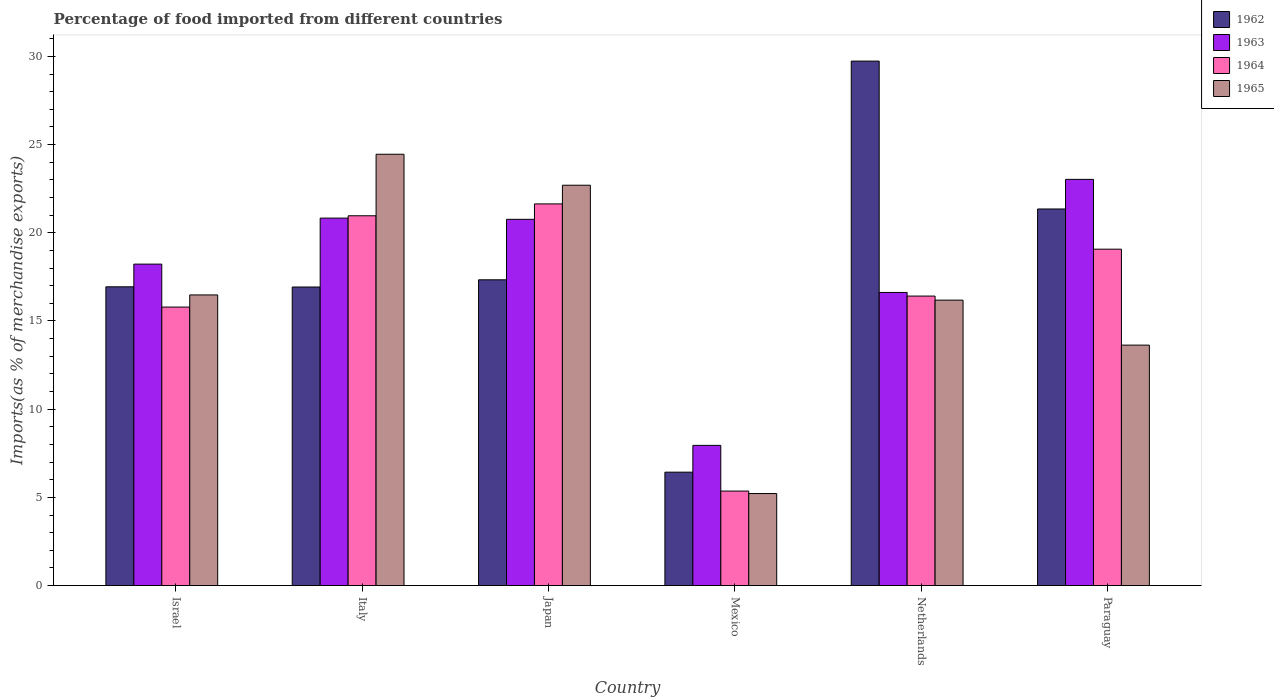How many different coloured bars are there?
Keep it short and to the point. 4. How many bars are there on the 6th tick from the right?
Your response must be concise. 4. What is the label of the 6th group of bars from the left?
Offer a terse response. Paraguay. In how many cases, is the number of bars for a given country not equal to the number of legend labels?
Your answer should be compact. 0. What is the percentage of imports to different countries in 1965 in Paraguay?
Provide a succinct answer. 13.63. Across all countries, what is the maximum percentage of imports to different countries in 1963?
Offer a very short reply. 23.03. Across all countries, what is the minimum percentage of imports to different countries in 1964?
Your answer should be very brief. 5.36. In which country was the percentage of imports to different countries in 1963 minimum?
Offer a very short reply. Mexico. What is the total percentage of imports to different countries in 1963 in the graph?
Ensure brevity in your answer.  107.42. What is the difference between the percentage of imports to different countries in 1964 in Italy and that in Mexico?
Offer a terse response. 15.61. What is the difference between the percentage of imports to different countries in 1964 in Paraguay and the percentage of imports to different countries in 1963 in Israel?
Offer a very short reply. 0.85. What is the average percentage of imports to different countries in 1963 per country?
Ensure brevity in your answer.  17.9. What is the difference between the percentage of imports to different countries of/in 1963 and percentage of imports to different countries of/in 1962 in Mexico?
Provide a short and direct response. 1.52. What is the ratio of the percentage of imports to different countries in 1965 in Japan to that in Netherlands?
Provide a succinct answer. 1.4. Is the percentage of imports to different countries in 1964 in Israel less than that in Mexico?
Give a very brief answer. No. Is the difference between the percentage of imports to different countries in 1963 in Italy and Paraguay greater than the difference between the percentage of imports to different countries in 1962 in Italy and Paraguay?
Ensure brevity in your answer.  Yes. What is the difference between the highest and the second highest percentage of imports to different countries in 1962?
Offer a very short reply. -4.02. What is the difference between the highest and the lowest percentage of imports to different countries in 1964?
Offer a very short reply. 16.28. Is the sum of the percentage of imports to different countries in 1965 in Italy and Mexico greater than the maximum percentage of imports to different countries in 1964 across all countries?
Provide a short and direct response. Yes. Is it the case that in every country, the sum of the percentage of imports to different countries in 1964 and percentage of imports to different countries in 1965 is greater than the sum of percentage of imports to different countries in 1962 and percentage of imports to different countries in 1963?
Give a very brief answer. No. What does the 1st bar from the right in Mexico represents?
Your answer should be very brief. 1965. Is it the case that in every country, the sum of the percentage of imports to different countries in 1964 and percentage of imports to different countries in 1963 is greater than the percentage of imports to different countries in 1965?
Ensure brevity in your answer.  Yes. How many bars are there?
Provide a succinct answer. 24. How many countries are there in the graph?
Provide a succinct answer. 6. Are the values on the major ticks of Y-axis written in scientific E-notation?
Ensure brevity in your answer.  No. Does the graph contain grids?
Provide a short and direct response. No. How many legend labels are there?
Offer a terse response. 4. What is the title of the graph?
Your answer should be very brief. Percentage of food imported from different countries. Does "1993" appear as one of the legend labels in the graph?
Make the answer very short. No. What is the label or title of the Y-axis?
Give a very brief answer. Imports(as % of merchandise exports). What is the Imports(as % of merchandise exports) in 1962 in Israel?
Ensure brevity in your answer.  16.94. What is the Imports(as % of merchandise exports) of 1963 in Israel?
Make the answer very short. 18.22. What is the Imports(as % of merchandise exports) of 1964 in Israel?
Make the answer very short. 15.79. What is the Imports(as % of merchandise exports) in 1965 in Israel?
Your answer should be compact. 16.48. What is the Imports(as % of merchandise exports) in 1962 in Italy?
Provide a short and direct response. 16.93. What is the Imports(as % of merchandise exports) in 1963 in Italy?
Offer a terse response. 20.83. What is the Imports(as % of merchandise exports) in 1964 in Italy?
Give a very brief answer. 20.97. What is the Imports(as % of merchandise exports) in 1965 in Italy?
Offer a terse response. 24.45. What is the Imports(as % of merchandise exports) of 1962 in Japan?
Ensure brevity in your answer.  17.34. What is the Imports(as % of merchandise exports) of 1963 in Japan?
Your answer should be compact. 20.76. What is the Imports(as % of merchandise exports) in 1964 in Japan?
Provide a short and direct response. 21.64. What is the Imports(as % of merchandise exports) of 1965 in Japan?
Keep it short and to the point. 22.7. What is the Imports(as % of merchandise exports) of 1962 in Mexico?
Make the answer very short. 6.43. What is the Imports(as % of merchandise exports) of 1963 in Mexico?
Provide a short and direct response. 7.95. What is the Imports(as % of merchandise exports) of 1964 in Mexico?
Offer a very short reply. 5.36. What is the Imports(as % of merchandise exports) in 1965 in Mexico?
Give a very brief answer. 5.22. What is the Imports(as % of merchandise exports) of 1962 in Netherlands?
Give a very brief answer. 29.73. What is the Imports(as % of merchandise exports) of 1963 in Netherlands?
Provide a short and direct response. 16.62. What is the Imports(as % of merchandise exports) in 1964 in Netherlands?
Make the answer very short. 16.41. What is the Imports(as % of merchandise exports) of 1965 in Netherlands?
Offer a very short reply. 16.18. What is the Imports(as % of merchandise exports) of 1962 in Paraguay?
Provide a short and direct response. 21.35. What is the Imports(as % of merchandise exports) of 1963 in Paraguay?
Your answer should be very brief. 23.03. What is the Imports(as % of merchandise exports) of 1964 in Paraguay?
Your response must be concise. 19.07. What is the Imports(as % of merchandise exports) of 1965 in Paraguay?
Your answer should be very brief. 13.63. Across all countries, what is the maximum Imports(as % of merchandise exports) of 1962?
Provide a succinct answer. 29.73. Across all countries, what is the maximum Imports(as % of merchandise exports) in 1963?
Your response must be concise. 23.03. Across all countries, what is the maximum Imports(as % of merchandise exports) in 1964?
Your answer should be compact. 21.64. Across all countries, what is the maximum Imports(as % of merchandise exports) in 1965?
Ensure brevity in your answer.  24.45. Across all countries, what is the minimum Imports(as % of merchandise exports) of 1962?
Keep it short and to the point. 6.43. Across all countries, what is the minimum Imports(as % of merchandise exports) in 1963?
Your response must be concise. 7.95. Across all countries, what is the minimum Imports(as % of merchandise exports) in 1964?
Provide a short and direct response. 5.36. Across all countries, what is the minimum Imports(as % of merchandise exports) of 1965?
Your answer should be very brief. 5.22. What is the total Imports(as % of merchandise exports) of 1962 in the graph?
Offer a very short reply. 108.71. What is the total Imports(as % of merchandise exports) of 1963 in the graph?
Your answer should be very brief. 107.42. What is the total Imports(as % of merchandise exports) in 1964 in the graph?
Your answer should be compact. 99.23. What is the total Imports(as % of merchandise exports) in 1965 in the graph?
Keep it short and to the point. 98.66. What is the difference between the Imports(as % of merchandise exports) in 1962 in Israel and that in Italy?
Your response must be concise. 0.01. What is the difference between the Imports(as % of merchandise exports) in 1963 in Israel and that in Italy?
Offer a terse response. -2.61. What is the difference between the Imports(as % of merchandise exports) in 1964 in Israel and that in Italy?
Give a very brief answer. -5.18. What is the difference between the Imports(as % of merchandise exports) of 1965 in Israel and that in Italy?
Keep it short and to the point. -7.97. What is the difference between the Imports(as % of merchandise exports) in 1962 in Israel and that in Japan?
Provide a succinct answer. -0.4. What is the difference between the Imports(as % of merchandise exports) of 1963 in Israel and that in Japan?
Make the answer very short. -2.54. What is the difference between the Imports(as % of merchandise exports) of 1964 in Israel and that in Japan?
Make the answer very short. -5.85. What is the difference between the Imports(as % of merchandise exports) of 1965 in Israel and that in Japan?
Your response must be concise. -6.22. What is the difference between the Imports(as % of merchandise exports) of 1962 in Israel and that in Mexico?
Keep it short and to the point. 10.51. What is the difference between the Imports(as % of merchandise exports) of 1963 in Israel and that in Mexico?
Your answer should be compact. 10.28. What is the difference between the Imports(as % of merchandise exports) in 1964 in Israel and that in Mexico?
Keep it short and to the point. 10.43. What is the difference between the Imports(as % of merchandise exports) in 1965 in Israel and that in Mexico?
Keep it short and to the point. 11.26. What is the difference between the Imports(as % of merchandise exports) in 1962 in Israel and that in Netherlands?
Provide a short and direct response. -12.8. What is the difference between the Imports(as % of merchandise exports) of 1963 in Israel and that in Netherlands?
Make the answer very short. 1.61. What is the difference between the Imports(as % of merchandise exports) of 1964 in Israel and that in Netherlands?
Offer a terse response. -0.62. What is the difference between the Imports(as % of merchandise exports) in 1965 in Israel and that in Netherlands?
Offer a very short reply. 0.3. What is the difference between the Imports(as % of merchandise exports) of 1962 in Israel and that in Paraguay?
Your answer should be very brief. -4.41. What is the difference between the Imports(as % of merchandise exports) in 1963 in Israel and that in Paraguay?
Ensure brevity in your answer.  -4.8. What is the difference between the Imports(as % of merchandise exports) in 1964 in Israel and that in Paraguay?
Make the answer very short. -3.28. What is the difference between the Imports(as % of merchandise exports) of 1965 in Israel and that in Paraguay?
Offer a very short reply. 2.85. What is the difference between the Imports(as % of merchandise exports) of 1962 in Italy and that in Japan?
Ensure brevity in your answer.  -0.41. What is the difference between the Imports(as % of merchandise exports) of 1963 in Italy and that in Japan?
Your response must be concise. 0.07. What is the difference between the Imports(as % of merchandise exports) of 1964 in Italy and that in Japan?
Ensure brevity in your answer.  -0.67. What is the difference between the Imports(as % of merchandise exports) of 1965 in Italy and that in Japan?
Ensure brevity in your answer.  1.76. What is the difference between the Imports(as % of merchandise exports) in 1962 in Italy and that in Mexico?
Your answer should be very brief. 10.5. What is the difference between the Imports(as % of merchandise exports) of 1963 in Italy and that in Mexico?
Offer a very short reply. 12.88. What is the difference between the Imports(as % of merchandise exports) in 1964 in Italy and that in Mexico?
Your response must be concise. 15.61. What is the difference between the Imports(as % of merchandise exports) in 1965 in Italy and that in Mexico?
Provide a succinct answer. 19.24. What is the difference between the Imports(as % of merchandise exports) in 1962 in Italy and that in Netherlands?
Ensure brevity in your answer.  -12.81. What is the difference between the Imports(as % of merchandise exports) of 1963 in Italy and that in Netherlands?
Your response must be concise. 4.21. What is the difference between the Imports(as % of merchandise exports) of 1964 in Italy and that in Netherlands?
Your answer should be very brief. 4.55. What is the difference between the Imports(as % of merchandise exports) of 1965 in Italy and that in Netherlands?
Provide a short and direct response. 8.27. What is the difference between the Imports(as % of merchandise exports) in 1962 in Italy and that in Paraguay?
Keep it short and to the point. -4.42. What is the difference between the Imports(as % of merchandise exports) of 1963 in Italy and that in Paraguay?
Give a very brief answer. -2.2. What is the difference between the Imports(as % of merchandise exports) in 1964 in Italy and that in Paraguay?
Your response must be concise. 1.89. What is the difference between the Imports(as % of merchandise exports) in 1965 in Italy and that in Paraguay?
Make the answer very short. 10.82. What is the difference between the Imports(as % of merchandise exports) in 1962 in Japan and that in Mexico?
Give a very brief answer. 10.91. What is the difference between the Imports(as % of merchandise exports) of 1963 in Japan and that in Mexico?
Offer a very short reply. 12.82. What is the difference between the Imports(as % of merchandise exports) of 1964 in Japan and that in Mexico?
Offer a very short reply. 16.28. What is the difference between the Imports(as % of merchandise exports) of 1965 in Japan and that in Mexico?
Your answer should be very brief. 17.48. What is the difference between the Imports(as % of merchandise exports) of 1962 in Japan and that in Netherlands?
Your response must be concise. -12.4. What is the difference between the Imports(as % of merchandise exports) of 1963 in Japan and that in Netherlands?
Provide a succinct answer. 4.15. What is the difference between the Imports(as % of merchandise exports) in 1964 in Japan and that in Netherlands?
Your answer should be very brief. 5.23. What is the difference between the Imports(as % of merchandise exports) in 1965 in Japan and that in Netherlands?
Offer a terse response. 6.51. What is the difference between the Imports(as % of merchandise exports) of 1962 in Japan and that in Paraguay?
Make the answer very short. -4.02. What is the difference between the Imports(as % of merchandise exports) of 1963 in Japan and that in Paraguay?
Ensure brevity in your answer.  -2.26. What is the difference between the Imports(as % of merchandise exports) of 1964 in Japan and that in Paraguay?
Your answer should be very brief. 2.57. What is the difference between the Imports(as % of merchandise exports) in 1965 in Japan and that in Paraguay?
Your response must be concise. 9.06. What is the difference between the Imports(as % of merchandise exports) of 1962 in Mexico and that in Netherlands?
Provide a short and direct response. -23.31. What is the difference between the Imports(as % of merchandise exports) in 1963 in Mexico and that in Netherlands?
Ensure brevity in your answer.  -8.67. What is the difference between the Imports(as % of merchandise exports) in 1964 in Mexico and that in Netherlands?
Offer a terse response. -11.05. What is the difference between the Imports(as % of merchandise exports) of 1965 in Mexico and that in Netherlands?
Make the answer very short. -10.97. What is the difference between the Imports(as % of merchandise exports) in 1962 in Mexico and that in Paraguay?
Your response must be concise. -14.92. What is the difference between the Imports(as % of merchandise exports) in 1963 in Mexico and that in Paraguay?
Make the answer very short. -15.08. What is the difference between the Imports(as % of merchandise exports) of 1964 in Mexico and that in Paraguay?
Make the answer very short. -13.71. What is the difference between the Imports(as % of merchandise exports) in 1965 in Mexico and that in Paraguay?
Keep it short and to the point. -8.42. What is the difference between the Imports(as % of merchandise exports) of 1962 in Netherlands and that in Paraguay?
Offer a terse response. 8.38. What is the difference between the Imports(as % of merchandise exports) in 1963 in Netherlands and that in Paraguay?
Ensure brevity in your answer.  -6.41. What is the difference between the Imports(as % of merchandise exports) in 1964 in Netherlands and that in Paraguay?
Your answer should be very brief. -2.66. What is the difference between the Imports(as % of merchandise exports) of 1965 in Netherlands and that in Paraguay?
Provide a succinct answer. 2.55. What is the difference between the Imports(as % of merchandise exports) of 1962 in Israel and the Imports(as % of merchandise exports) of 1963 in Italy?
Ensure brevity in your answer.  -3.89. What is the difference between the Imports(as % of merchandise exports) in 1962 in Israel and the Imports(as % of merchandise exports) in 1964 in Italy?
Provide a succinct answer. -4.03. What is the difference between the Imports(as % of merchandise exports) in 1962 in Israel and the Imports(as % of merchandise exports) in 1965 in Italy?
Offer a terse response. -7.51. What is the difference between the Imports(as % of merchandise exports) in 1963 in Israel and the Imports(as % of merchandise exports) in 1964 in Italy?
Offer a terse response. -2.74. What is the difference between the Imports(as % of merchandise exports) of 1963 in Israel and the Imports(as % of merchandise exports) of 1965 in Italy?
Offer a terse response. -6.23. What is the difference between the Imports(as % of merchandise exports) of 1964 in Israel and the Imports(as % of merchandise exports) of 1965 in Italy?
Provide a short and direct response. -8.66. What is the difference between the Imports(as % of merchandise exports) in 1962 in Israel and the Imports(as % of merchandise exports) in 1963 in Japan?
Give a very brief answer. -3.83. What is the difference between the Imports(as % of merchandise exports) of 1962 in Israel and the Imports(as % of merchandise exports) of 1964 in Japan?
Offer a very short reply. -4.7. What is the difference between the Imports(as % of merchandise exports) in 1962 in Israel and the Imports(as % of merchandise exports) in 1965 in Japan?
Make the answer very short. -5.76. What is the difference between the Imports(as % of merchandise exports) of 1963 in Israel and the Imports(as % of merchandise exports) of 1964 in Japan?
Make the answer very short. -3.41. What is the difference between the Imports(as % of merchandise exports) of 1963 in Israel and the Imports(as % of merchandise exports) of 1965 in Japan?
Offer a terse response. -4.47. What is the difference between the Imports(as % of merchandise exports) of 1964 in Israel and the Imports(as % of merchandise exports) of 1965 in Japan?
Provide a succinct answer. -6.91. What is the difference between the Imports(as % of merchandise exports) of 1962 in Israel and the Imports(as % of merchandise exports) of 1963 in Mexico?
Offer a terse response. 8.99. What is the difference between the Imports(as % of merchandise exports) in 1962 in Israel and the Imports(as % of merchandise exports) in 1964 in Mexico?
Your response must be concise. 11.58. What is the difference between the Imports(as % of merchandise exports) of 1962 in Israel and the Imports(as % of merchandise exports) of 1965 in Mexico?
Offer a very short reply. 11.72. What is the difference between the Imports(as % of merchandise exports) in 1963 in Israel and the Imports(as % of merchandise exports) in 1964 in Mexico?
Give a very brief answer. 12.87. What is the difference between the Imports(as % of merchandise exports) in 1963 in Israel and the Imports(as % of merchandise exports) in 1965 in Mexico?
Give a very brief answer. 13.01. What is the difference between the Imports(as % of merchandise exports) in 1964 in Israel and the Imports(as % of merchandise exports) in 1965 in Mexico?
Keep it short and to the point. 10.57. What is the difference between the Imports(as % of merchandise exports) of 1962 in Israel and the Imports(as % of merchandise exports) of 1963 in Netherlands?
Give a very brief answer. 0.32. What is the difference between the Imports(as % of merchandise exports) of 1962 in Israel and the Imports(as % of merchandise exports) of 1964 in Netherlands?
Keep it short and to the point. 0.53. What is the difference between the Imports(as % of merchandise exports) in 1962 in Israel and the Imports(as % of merchandise exports) in 1965 in Netherlands?
Provide a succinct answer. 0.76. What is the difference between the Imports(as % of merchandise exports) in 1963 in Israel and the Imports(as % of merchandise exports) in 1964 in Netherlands?
Keep it short and to the point. 1.81. What is the difference between the Imports(as % of merchandise exports) in 1963 in Israel and the Imports(as % of merchandise exports) in 1965 in Netherlands?
Make the answer very short. 2.04. What is the difference between the Imports(as % of merchandise exports) of 1964 in Israel and the Imports(as % of merchandise exports) of 1965 in Netherlands?
Provide a short and direct response. -0.39. What is the difference between the Imports(as % of merchandise exports) of 1962 in Israel and the Imports(as % of merchandise exports) of 1963 in Paraguay?
Keep it short and to the point. -6.09. What is the difference between the Imports(as % of merchandise exports) in 1962 in Israel and the Imports(as % of merchandise exports) in 1964 in Paraguay?
Offer a terse response. -2.13. What is the difference between the Imports(as % of merchandise exports) of 1962 in Israel and the Imports(as % of merchandise exports) of 1965 in Paraguay?
Offer a terse response. 3.31. What is the difference between the Imports(as % of merchandise exports) in 1963 in Israel and the Imports(as % of merchandise exports) in 1964 in Paraguay?
Keep it short and to the point. -0.85. What is the difference between the Imports(as % of merchandise exports) in 1963 in Israel and the Imports(as % of merchandise exports) in 1965 in Paraguay?
Your answer should be compact. 4.59. What is the difference between the Imports(as % of merchandise exports) in 1964 in Israel and the Imports(as % of merchandise exports) in 1965 in Paraguay?
Offer a terse response. 2.16. What is the difference between the Imports(as % of merchandise exports) in 1962 in Italy and the Imports(as % of merchandise exports) in 1963 in Japan?
Your answer should be compact. -3.84. What is the difference between the Imports(as % of merchandise exports) of 1962 in Italy and the Imports(as % of merchandise exports) of 1964 in Japan?
Offer a very short reply. -4.71. What is the difference between the Imports(as % of merchandise exports) in 1962 in Italy and the Imports(as % of merchandise exports) in 1965 in Japan?
Make the answer very short. -5.77. What is the difference between the Imports(as % of merchandise exports) in 1963 in Italy and the Imports(as % of merchandise exports) in 1964 in Japan?
Make the answer very short. -0.81. What is the difference between the Imports(as % of merchandise exports) in 1963 in Italy and the Imports(as % of merchandise exports) in 1965 in Japan?
Keep it short and to the point. -1.86. What is the difference between the Imports(as % of merchandise exports) in 1964 in Italy and the Imports(as % of merchandise exports) in 1965 in Japan?
Keep it short and to the point. -1.73. What is the difference between the Imports(as % of merchandise exports) in 1962 in Italy and the Imports(as % of merchandise exports) in 1963 in Mexico?
Keep it short and to the point. 8.98. What is the difference between the Imports(as % of merchandise exports) in 1962 in Italy and the Imports(as % of merchandise exports) in 1964 in Mexico?
Keep it short and to the point. 11.57. What is the difference between the Imports(as % of merchandise exports) in 1962 in Italy and the Imports(as % of merchandise exports) in 1965 in Mexico?
Offer a very short reply. 11.71. What is the difference between the Imports(as % of merchandise exports) of 1963 in Italy and the Imports(as % of merchandise exports) of 1964 in Mexico?
Offer a very short reply. 15.48. What is the difference between the Imports(as % of merchandise exports) of 1963 in Italy and the Imports(as % of merchandise exports) of 1965 in Mexico?
Make the answer very short. 15.62. What is the difference between the Imports(as % of merchandise exports) of 1964 in Italy and the Imports(as % of merchandise exports) of 1965 in Mexico?
Offer a very short reply. 15.75. What is the difference between the Imports(as % of merchandise exports) in 1962 in Italy and the Imports(as % of merchandise exports) in 1963 in Netherlands?
Keep it short and to the point. 0.31. What is the difference between the Imports(as % of merchandise exports) in 1962 in Italy and the Imports(as % of merchandise exports) in 1964 in Netherlands?
Your answer should be compact. 0.51. What is the difference between the Imports(as % of merchandise exports) in 1962 in Italy and the Imports(as % of merchandise exports) in 1965 in Netherlands?
Your answer should be very brief. 0.74. What is the difference between the Imports(as % of merchandise exports) of 1963 in Italy and the Imports(as % of merchandise exports) of 1964 in Netherlands?
Offer a terse response. 4.42. What is the difference between the Imports(as % of merchandise exports) of 1963 in Italy and the Imports(as % of merchandise exports) of 1965 in Netherlands?
Offer a very short reply. 4.65. What is the difference between the Imports(as % of merchandise exports) of 1964 in Italy and the Imports(as % of merchandise exports) of 1965 in Netherlands?
Provide a short and direct response. 4.78. What is the difference between the Imports(as % of merchandise exports) of 1962 in Italy and the Imports(as % of merchandise exports) of 1963 in Paraguay?
Ensure brevity in your answer.  -6.1. What is the difference between the Imports(as % of merchandise exports) in 1962 in Italy and the Imports(as % of merchandise exports) in 1964 in Paraguay?
Keep it short and to the point. -2.14. What is the difference between the Imports(as % of merchandise exports) in 1962 in Italy and the Imports(as % of merchandise exports) in 1965 in Paraguay?
Your answer should be compact. 3.29. What is the difference between the Imports(as % of merchandise exports) in 1963 in Italy and the Imports(as % of merchandise exports) in 1964 in Paraguay?
Your answer should be compact. 1.76. What is the difference between the Imports(as % of merchandise exports) of 1963 in Italy and the Imports(as % of merchandise exports) of 1965 in Paraguay?
Provide a succinct answer. 7.2. What is the difference between the Imports(as % of merchandise exports) of 1964 in Italy and the Imports(as % of merchandise exports) of 1965 in Paraguay?
Your answer should be very brief. 7.33. What is the difference between the Imports(as % of merchandise exports) in 1962 in Japan and the Imports(as % of merchandise exports) in 1963 in Mexico?
Your answer should be compact. 9.39. What is the difference between the Imports(as % of merchandise exports) of 1962 in Japan and the Imports(as % of merchandise exports) of 1964 in Mexico?
Your answer should be compact. 11.98. What is the difference between the Imports(as % of merchandise exports) of 1962 in Japan and the Imports(as % of merchandise exports) of 1965 in Mexico?
Make the answer very short. 12.12. What is the difference between the Imports(as % of merchandise exports) in 1963 in Japan and the Imports(as % of merchandise exports) in 1964 in Mexico?
Make the answer very short. 15.41. What is the difference between the Imports(as % of merchandise exports) of 1963 in Japan and the Imports(as % of merchandise exports) of 1965 in Mexico?
Make the answer very short. 15.55. What is the difference between the Imports(as % of merchandise exports) of 1964 in Japan and the Imports(as % of merchandise exports) of 1965 in Mexico?
Offer a very short reply. 16.42. What is the difference between the Imports(as % of merchandise exports) in 1962 in Japan and the Imports(as % of merchandise exports) in 1963 in Netherlands?
Ensure brevity in your answer.  0.72. What is the difference between the Imports(as % of merchandise exports) of 1962 in Japan and the Imports(as % of merchandise exports) of 1964 in Netherlands?
Keep it short and to the point. 0.92. What is the difference between the Imports(as % of merchandise exports) of 1962 in Japan and the Imports(as % of merchandise exports) of 1965 in Netherlands?
Make the answer very short. 1.15. What is the difference between the Imports(as % of merchandise exports) in 1963 in Japan and the Imports(as % of merchandise exports) in 1964 in Netherlands?
Make the answer very short. 4.35. What is the difference between the Imports(as % of merchandise exports) of 1963 in Japan and the Imports(as % of merchandise exports) of 1965 in Netherlands?
Keep it short and to the point. 4.58. What is the difference between the Imports(as % of merchandise exports) of 1964 in Japan and the Imports(as % of merchandise exports) of 1965 in Netherlands?
Make the answer very short. 5.46. What is the difference between the Imports(as % of merchandise exports) of 1962 in Japan and the Imports(as % of merchandise exports) of 1963 in Paraguay?
Your answer should be compact. -5.69. What is the difference between the Imports(as % of merchandise exports) in 1962 in Japan and the Imports(as % of merchandise exports) in 1964 in Paraguay?
Offer a very short reply. -1.74. What is the difference between the Imports(as % of merchandise exports) in 1962 in Japan and the Imports(as % of merchandise exports) in 1965 in Paraguay?
Your answer should be compact. 3.7. What is the difference between the Imports(as % of merchandise exports) of 1963 in Japan and the Imports(as % of merchandise exports) of 1964 in Paraguay?
Offer a terse response. 1.69. What is the difference between the Imports(as % of merchandise exports) of 1963 in Japan and the Imports(as % of merchandise exports) of 1965 in Paraguay?
Offer a terse response. 7.13. What is the difference between the Imports(as % of merchandise exports) in 1964 in Japan and the Imports(as % of merchandise exports) in 1965 in Paraguay?
Keep it short and to the point. 8.01. What is the difference between the Imports(as % of merchandise exports) of 1962 in Mexico and the Imports(as % of merchandise exports) of 1963 in Netherlands?
Your answer should be very brief. -10.19. What is the difference between the Imports(as % of merchandise exports) in 1962 in Mexico and the Imports(as % of merchandise exports) in 1964 in Netherlands?
Provide a short and direct response. -9.98. What is the difference between the Imports(as % of merchandise exports) of 1962 in Mexico and the Imports(as % of merchandise exports) of 1965 in Netherlands?
Your answer should be compact. -9.75. What is the difference between the Imports(as % of merchandise exports) in 1963 in Mexico and the Imports(as % of merchandise exports) in 1964 in Netherlands?
Your answer should be compact. -8.46. What is the difference between the Imports(as % of merchandise exports) of 1963 in Mexico and the Imports(as % of merchandise exports) of 1965 in Netherlands?
Provide a succinct answer. -8.23. What is the difference between the Imports(as % of merchandise exports) of 1964 in Mexico and the Imports(as % of merchandise exports) of 1965 in Netherlands?
Your response must be concise. -10.83. What is the difference between the Imports(as % of merchandise exports) in 1962 in Mexico and the Imports(as % of merchandise exports) in 1963 in Paraguay?
Your answer should be very brief. -16.6. What is the difference between the Imports(as % of merchandise exports) in 1962 in Mexico and the Imports(as % of merchandise exports) in 1964 in Paraguay?
Provide a short and direct response. -12.64. What is the difference between the Imports(as % of merchandise exports) of 1962 in Mexico and the Imports(as % of merchandise exports) of 1965 in Paraguay?
Your answer should be very brief. -7.2. What is the difference between the Imports(as % of merchandise exports) in 1963 in Mexico and the Imports(as % of merchandise exports) in 1964 in Paraguay?
Provide a short and direct response. -11.12. What is the difference between the Imports(as % of merchandise exports) of 1963 in Mexico and the Imports(as % of merchandise exports) of 1965 in Paraguay?
Your answer should be compact. -5.68. What is the difference between the Imports(as % of merchandise exports) in 1964 in Mexico and the Imports(as % of merchandise exports) in 1965 in Paraguay?
Make the answer very short. -8.27. What is the difference between the Imports(as % of merchandise exports) of 1962 in Netherlands and the Imports(as % of merchandise exports) of 1963 in Paraguay?
Give a very brief answer. 6.71. What is the difference between the Imports(as % of merchandise exports) of 1962 in Netherlands and the Imports(as % of merchandise exports) of 1964 in Paraguay?
Provide a succinct answer. 10.66. What is the difference between the Imports(as % of merchandise exports) of 1962 in Netherlands and the Imports(as % of merchandise exports) of 1965 in Paraguay?
Make the answer very short. 16.1. What is the difference between the Imports(as % of merchandise exports) of 1963 in Netherlands and the Imports(as % of merchandise exports) of 1964 in Paraguay?
Give a very brief answer. -2.45. What is the difference between the Imports(as % of merchandise exports) in 1963 in Netherlands and the Imports(as % of merchandise exports) in 1965 in Paraguay?
Make the answer very short. 2.99. What is the difference between the Imports(as % of merchandise exports) of 1964 in Netherlands and the Imports(as % of merchandise exports) of 1965 in Paraguay?
Make the answer very short. 2.78. What is the average Imports(as % of merchandise exports) of 1962 per country?
Keep it short and to the point. 18.12. What is the average Imports(as % of merchandise exports) of 1963 per country?
Offer a very short reply. 17.9. What is the average Imports(as % of merchandise exports) of 1964 per country?
Make the answer very short. 16.54. What is the average Imports(as % of merchandise exports) of 1965 per country?
Your answer should be compact. 16.44. What is the difference between the Imports(as % of merchandise exports) in 1962 and Imports(as % of merchandise exports) in 1963 in Israel?
Provide a succinct answer. -1.29. What is the difference between the Imports(as % of merchandise exports) in 1962 and Imports(as % of merchandise exports) in 1964 in Israel?
Offer a terse response. 1.15. What is the difference between the Imports(as % of merchandise exports) of 1962 and Imports(as % of merchandise exports) of 1965 in Israel?
Offer a very short reply. 0.46. What is the difference between the Imports(as % of merchandise exports) of 1963 and Imports(as % of merchandise exports) of 1964 in Israel?
Your answer should be compact. 2.43. What is the difference between the Imports(as % of merchandise exports) in 1963 and Imports(as % of merchandise exports) in 1965 in Israel?
Offer a terse response. 1.75. What is the difference between the Imports(as % of merchandise exports) in 1964 and Imports(as % of merchandise exports) in 1965 in Israel?
Your answer should be very brief. -0.69. What is the difference between the Imports(as % of merchandise exports) of 1962 and Imports(as % of merchandise exports) of 1963 in Italy?
Offer a very short reply. -3.91. What is the difference between the Imports(as % of merchandise exports) of 1962 and Imports(as % of merchandise exports) of 1964 in Italy?
Provide a short and direct response. -4.04. What is the difference between the Imports(as % of merchandise exports) of 1962 and Imports(as % of merchandise exports) of 1965 in Italy?
Your response must be concise. -7.53. What is the difference between the Imports(as % of merchandise exports) of 1963 and Imports(as % of merchandise exports) of 1964 in Italy?
Offer a terse response. -0.13. What is the difference between the Imports(as % of merchandise exports) in 1963 and Imports(as % of merchandise exports) in 1965 in Italy?
Provide a short and direct response. -3.62. What is the difference between the Imports(as % of merchandise exports) in 1964 and Imports(as % of merchandise exports) in 1965 in Italy?
Provide a succinct answer. -3.49. What is the difference between the Imports(as % of merchandise exports) of 1962 and Imports(as % of merchandise exports) of 1963 in Japan?
Your answer should be very brief. -3.43. What is the difference between the Imports(as % of merchandise exports) of 1962 and Imports(as % of merchandise exports) of 1964 in Japan?
Give a very brief answer. -4.3. What is the difference between the Imports(as % of merchandise exports) in 1962 and Imports(as % of merchandise exports) in 1965 in Japan?
Give a very brief answer. -5.36. What is the difference between the Imports(as % of merchandise exports) of 1963 and Imports(as % of merchandise exports) of 1964 in Japan?
Your answer should be very brief. -0.87. What is the difference between the Imports(as % of merchandise exports) of 1963 and Imports(as % of merchandise exports) of 1965 in Japan?
Make the answer very short. -1.93. What is the difference between the Imports(as % of merchandise exports) in 1964 and Imports(as % of merchandise exports) in 1965 in Japan?
Give a very brief answer. -1.06. What is the difference between the Imports(as % of merchandise exports) in 1962 and Imports(as % of merchandise exports) in 1963 in Mexico?
Give a very brief answer. -1.52. What is the difference between the Imports(as % of merchandise exports) in 1962 and Imports(as % of merchandise exports) in 1964 in Mexico?
Provide a short and direct response. 1.07. What is the difference between the Imports(as % of merchandise exports) in 1962 and Imports(as % of merchandise exports) in 1965 in Mexico?
Your answer should be compact. 1.21. What is the difference between the Imports(as % of merchandise exports) in 1963 and Imports(as % of merchandise exports) in 1964 in Mexico?
Your answer should be very brief. 2.59. What is the difference between the Imports(as % of merchandise exports) in 1963 and Imports(as % of merchandise exports) in 1965 in Mexico?
Offer a terse response. 2.73. What is the difference between the Imports(as % of merchandise exports) in 1964 and Imports(as % of merchandise exports) in 1965 in Mexico?
Your answer should be very brief. 0.14. What is the difference between the Imports(as % of merchandise exports) in 1962 and Imports(as % of merchandise exports) in 1963 in Netherlands?
Offer a terse response. 13.12. What is the difference between the Imports(as % of merchandise exports) in 1962 and Imports(as % of merchandise exports) in 1964 in Netherlands?
Provide a short and direct response. 13.32. What is the difference between the Imports(as % of merchandise exports) of 1962 and Imports(as % of merchandise exports) of 1965 in Netherlands?
Your answer should be compact. 13.55. What is the difference between the Imports(as % of merchandise exports) of 1963 and Imports(as % of merchandise exports) of 1964 in Netherlands?
Your response must be concise. 0.21. What is the difference between the Imports(as % of merchandise exports) in 1963 and Imports(as % of merchandise exports) in 1965 in Netherlands?
Your answer should be compact. 0.44. What is the difference between the Imports(as % of merchandise exports) of 1964 and Imports(as % of merchandise exports) of 1965 in Netherlands?
Provide a short and direct response. 0.23. What is the difference between the Imports(as % of merchandise exports) in 1962 and Imports(as % of merchandise exports) in 1963 in Paraguay?
Provide a short and direct response. -1.68. What is the difference between the Imports(as % of merchandise exports) of 1962 and Imports(as % of merchandise exports) of 1964 in Paraguay?
Offer a very short reply. 2.28. What is the difference between the Imports(as % of merchandise exports) of 1962 and Imports(as % of merchandise exports) of 1965 in Paraguay?
Make the answer very short. 7.72. What is the difference between the Imports(as % of merchandise exports) in 1963 and Imports(as % of merchandise exports) in 1964 in Paraguay?
Offer a very short reply. 3.96. What is the difference between the Imports(as % of merchandise exports) of 1963 and Imports(as % of merchandise exports) of 1965 in Paraguay?
Give a very brief answer. 9.4. What is the difference between the Imports(as % of merchandise exports) in 1964 and Imports(as % of merchandise exports) in 1965 in Paraguay?
Keep it short and to the point. 5.44. What is the ratio of the Imports(as % of merchandise exports) of 1963 in Israel to that in Italy?
Give a very brief answer. 0.87. What is the ratio of the Imports(as % of merchandise exports) of 1964 in Israel to that in Italy?
Your answer should be very brief. 0.75. What is the ratio of the Imports(as % of merchandise exports) of 1965 in Israel to that in Italy?
Offer a very short reply. 0.67. What is the ratio of the Imports(as % of merchandise exports) of 1962 in Israel to that in Japan?
Give a very brief answer. 0.98. What is the ratio of the Imports(as % of merchandise exports) of 1963 in Israel to that in Japan?
Offer a very short reply. 0.88. What is the ratio of the Imports(as % of merchandise exports) in 1964 in Israel to that in Japan?
Offer a very short reply. 0.73. What is the ratio of the Imports(as % of merchandise exports) in 1965 in Israel to that in Japan?
Your answer should be very brief. 0.73. What is the ratio of the Imports(as % of merchandise exports) of 1962 in Israel to that in Mexico?
Keep it short and to the point. 2.63. What is the ratio of the Imports(as % of merchandise exports) of 1963 in Israel to that in Mexico?
Offer a very short reply. 2.29. What is the ratio of the Imports(as % of merchandise exports) in 1964 in Israel to that in Mexico?
Provide a short and direct response. 2.95. What is the ratio of the Imports(as % of merchandise exports) in 1965 in Israel to that in Mexico?
Offer a very short reply. 3.16. What is the ratio of the Imports(as % of merchandise exports) of 1962 in Israel to that in Netherlands?
Make the answer very short. 0.57. What is the ratio of the Imports(as % of merchandise exports) in 1963 in Israel to that in Netherlands?
Keep it short and to the point. 1.1. What is the ratio of the Imports(as % of merchandise exports) of 1965 in Israel to that in Netherlands?
Provide a short and direct response. 1.02. What is the ratio of the Imports(as % of merchandise exports) in 1962 in Israel to that in Paraguay?
Your answer should be very brief. 0.79. What is the ratio of the Imports(as % of merchandise exports) of 1963 in Israel to that in Paraguay?
Your answer should be very brief. 0.79. What is the ratio of the Imports(as % of merchandise exports) in 1964 in Israel to that in Paraguay?
Provide a short and direct response. 0.83. What is the ratio of the Imports(as % of merchandise exports) of 1965 in Israel to that in Paraguay?
Your answer should be compact. 1.21. What is the ratio of the Imports(as % of merchandise exports) of 1962 in Italy to that in Japan?
Your answer should be very brief. 0.98. What is the ratio of the Imports(as % of merchandise exports) of 1963 in Italy to that in Japan?
Provide a succinct answer. 1. What is the ratio of the Imports(as % of merchandise exports) of 1964 in Italy to that in Japan?
Offer a very short reply. 0.97. What is the ratio of the Imports(as % of merchandise exports) in 1965 in Italy to that in Japan?
Your answer should be very brief. 1.08. What is the ratio of the Imports(as % of merchandise exports) in 1962 in Italy to that in Mexico?
Your answer should be very brief. 2.63. What is the ratio of the Imports(as % of merchandise exports) in 1963 in Italy to that in Mexico?
Provide a short and direct response. 2.62. What is the ratio of the Imports(as % of merchandise exports) of 1964 in Italy to that in Mexico?
Ensure brevity in your answer.  3.91. What is the ratio of the Imports(as % of merchandise exports) in 1965 in Italy to that in Mexico?
Ensure brevity in your answer.  4.69. What is the ratio of the Imports(as % of merchandise exports) in 1962 in Italy to that in Netherlands?
Offer a terse response. 0.57. What is the ratio of the Imports(as % of merchandise exports) of 1963 in Italy to that in Netherlands?
Your answer should be compact. 1.25. What is the ratio of the Imports(as % of merchandise exports) in 1964 in Italy to that in Netherlands?
Keep it short and to the point. 1.28. What is the ratio of the Imports(as % of merchandise exports) in 1965 in Italy to that in Netherlands?
Provide a short and direct response. 1.51. What is the ratio of the Imports(as % of merchandise exports) in 1962 in Italy to that in Paraguay?
Ensure brevity in your answer.  0.79. What is the ratio of the Imports(as % of merchandise exports) of 1963 in Italy to that in Paraguay?
Provide a short and direct response. 0.9. What is the ratio of the Imports(as % of merchandise exports) in 1964 in Italy to that in Paraguay?
Keep it short and to the point. 1.1. What is the ratio of the Imports(as % of merchandise exports) of 1965 in Italy to that in Paraguay?
Keep it short and to the point. 1.79. What is the ratio of the Imports(as % of merchandise exports) of 1962 in Japan to that in Mexico?
Offer a very short reply. 2.7. What is the ratio of the Imports(as % of merchandise exports) in 1963 in Japan to that in Mexico?
Keep it short and to the point. 2.61. What is the ratio of the Imports(as % of merchandise exports) in 1964 in Japan to that in Mexico?
Provide a short and direct response. 4.04. What is the ratio of the Imports(as % of merchandise exports) of 1965 in Japan to that in Mexico?
Offer a terse response. 4.35. What is the ratio of the Imports(as % of merchandise exports) of 1962 in Japan to that in Netherlands?
Your response must be concise. 0.58. What is the ratio of the Imports(as % of merchandise exports) in 1963 in Japan to that in Netherlands?
Provide a succinct answer. 1.25. What is the ratio of the Imports(as % of merchandise exports) of 1964 in Japan to that in Netherlands?
Make the answer very short. 1.32. What is the ratio of the Imports(as % of merchandise exports) of 1965 in Japan to that in Netherlands?
Make the answer very short. 1.4. What is the ratio of the Imports(as % of merchandise exports) in 1962 in Japan to that in Paraguay?
Offer a terse response. 0.81. What is the ratio of the Imports(as % of merchandise exports) of 1963 in Japan to that in Paraguay?
Provide a short and direct response. 0.9. What is the ratio of the Imports(as % of merchandise exports) in 1964 in Japan to that in Paraguay?
Give a very brief answer. 1.13. What is the ratio of the Imports(as % of merchandise exports) of 1965 in Japan to that in Paraguay?
Your response must be concise. 1.67. What is the ratio of the Imports(as % of merchandise exports) of 1962 in Mexico to that in Netherlands?
Your response must be concise. 0.22. What is the ratio of the Imports(as % of merchandise exports) of 1963 in Mexico to that in Netherlands?
Ensure brevity in your answer.  0.48. What is the ratio of the Imports(as % of merchandise exports) of 1964 in Mexico to that in Netherlands?
Your answer should be very brief. 0.33. What is the ratio of the Imports(as % of merchandise exports) of 1965 in Mexico to that in Netherlands?
Provide a short and direct response. 0.32. What is the ratio of the Imports(as % of merchandise exports) in 1962 in Mexico to that in Paraguay?
Your response must be concise. 0.3. What is the ratio of the Imports(as % of merchandise exports) of 1963 in Mexico to that in Paraguay?
Provide a short and direct response. 0.35. What is the ratio of the Imports(as % of merchandise exports) in 1964 in Mexico to that in Paraguay?
Make the answer very short. 0.28. What is the ratio of the Imports(as % of merchandise exports) in 1965 in Mexico to that in Paraguay?
Offer a very short reply. 0.38. What is the ratio of the Imports(as % of merchandise exports) in 1962 in Netherlands to that in Paraguay?
Offer a terse response. 1.39. What is the ratio of the Imports(as % of merchandise exports) in 1963 in Netherlands to that in Paraguay?
Make the answer very short. 0.72. What is the ratio of the Imports(as % of merchandise exports) of 1964 in Netherlands to that in Paraguay?
Make the answer very short. 0.86. What is the ratio of the Imports(as % of merchandise exports) of 1965 in Netherlands to that in Paraguay?
Your answer should be very brief. 1.19. What is the difference between the highest and the second highest Imports(as % of merchandise exports) of 1962?
Your response must be concise. 8.38. What is the difference between the highest and the second highest Imports(as % of merchandise exports) in 1963?
Offer a terse response. 2.2. What is the difference between the highest and the second highest Imports(as % of merchandise exports) in 1964?
Your answer should be very brief. 0.67. What is the difference between the highest and the second highest Imports(as % of merchandise exports) in 1965?
Your answer should be compact. 1.76. What is the difference between the highest and the lowest Imports(as % of merchandise exports) in 1962?
Your answer should be very brief. 23.31. What is the difference between the highest and the lowest Imports(as % of merchandise exports) of 1963?
Your answer should be very brief. 15.08. What is the difference between the highest and the lowest Imports(as % of merchandise exports) of 1964?
Your response must be concise. 16.28. What is the difference between the highest and the lowest Imports(as % of merchandise exports) of 1965?
Give a very brief answer. 19.24. 